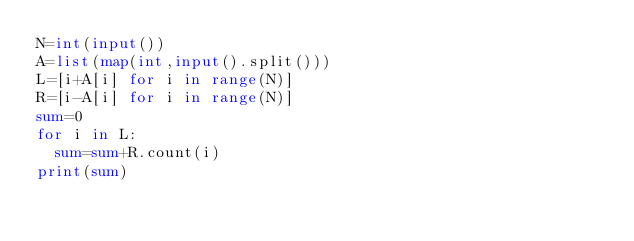Convert code to text. <code><loc_0><loc_0><loc_500><loc_500><_Python_>N=int(input())
A=list(map(int,input().split()))
L=[i+A[i] for i in range(N)]
R=[i-A[i] for i in range(N)]
sum=0
for i in L:
  sum=sum+R.count(i)
print(sum)</code> 